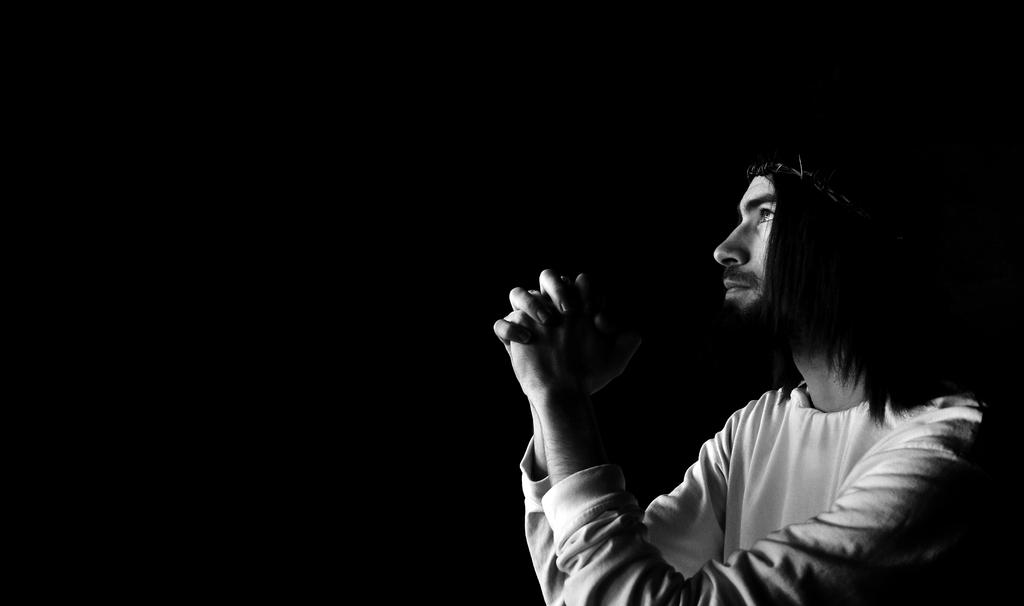What is the color scheme of the image? The image is black and white. Can you describe the person in the image? There is a man in the image. What is the man doing with his hands? The man is holding his hands together. What type of stitch is the man using to sew the wire in the image? There is no stitch or wire present in the image; it only features a man holding his hands together. 